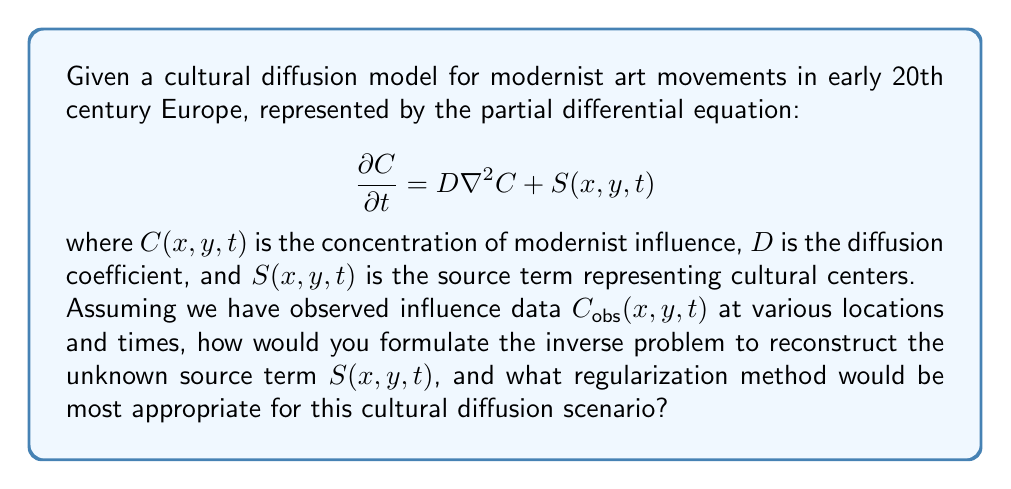Show me your answer to this math problem. To formulate the inverse problem and determine an appropriate regularization method, we can follow these steps:

1. Define the forward problem:
   The forward problem is given by the partial differential equation:
   $$\frac{\partial C}{\partial t} = D\nabla^2C + S(x,y,t)$$
   with initial and boundary conditions.

2. Formulate the inverse problem:
   The goal is to find $S(x,y,t)$ given $C_{obs}(x,y,t)$. This can be expressed as minimizing the misfit functional:
   $$J(S) = \frac{1}{2}\int_{\Omega}\int_0^T |C(x,y,t) - C_{obs}(x,y,t)|^2 dx dy dt$$

3. Ill-posedness:
   This inverse problem is likely ill-posed due to the smoothing nature of diffusion and potential noise in observations.

4. Regularization:
   To address ill-posedness, we need to add regularization. For cultural diffusion, Tikhonov regularization with spatial and temporal smoothness constraints would be appropriate:
   $$J_{reg}(S) = J(S) + \alpha_1\int_{\Omega}\int_0^T |\nabla S|^2 dx dy dt + \alpha_2\int_{\Omega}\int_0^T |\frac{\partial S}{\partial t}|^2 dx dy dt$$
   where $\alpha_1$ and $\alpha_2$ are regularization parameters.

5. Justification for regularization choice:
   - Spatial smoothness ($\alpha_1$ term) assumes cultural influence spreads gradually across geographic areas.
   - Temporal smoothness ($\alpha_2$ term) assumes cultural trends evolve slowly over time.
   - This regularization preserves sharp features that might represent distinct cultural centers while smoothing out noise.

6. Solution method:
   The regularized problem can be solved using iterative methods such as the conjugate gradient method or the L-BFGS algorithm, which are suitable for large-scale problems typical in spatiotemporal cultural modeling.

7. Parameter selection:
   Regularization parameters $\alpha_1$ and $\alpha_2$ can be chosen using methods like the L-curve or generalized cross-validation, balancing data fit and solution smoothness.

This approach allows for the reconstruction of cultural diffusion patterns while accounting for the inherent uncertainties and complexities in historical data.
Answer: Minimize $J_{reg}(S) = \frac{1}{2}\int_{\Omega}\int_0^T |C(x,y,t) - C_{obs}(x,y,t)|^2 dx dy dt + \alpha_1\int_{\Omega}\int_0^T |\nabla S|^2 dx dy dt + \alpha_2\int_{\Omega}\int_0^T |\frac{\partial S}{\partial t}|^2 dx dy dt$ using iterative methods. 